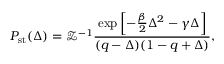<formula> <loc_0><loc_0><loc_500><loc_500>P _ { s t } ( \Delta ) = \mathcal { Z } ^ { - 1 } \frac { e x p \left [ - \frac { \beta } { 2 } \Delta ^ { 2 } - \gamma \Delta \right ] } { ( q - \Delta ) ( 1 - q + \Delta ) } ,</formula> 